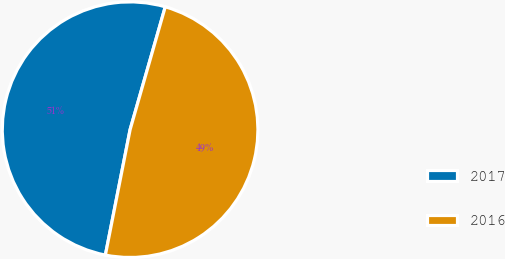Convert chart to OTSL. <chart><loc_0><loc_0><loc_500><loc_500><pie_chart><fcel>2017<fcel>2016<nl><fcel>51.34%<fcel>48.66%<nl></chart> 